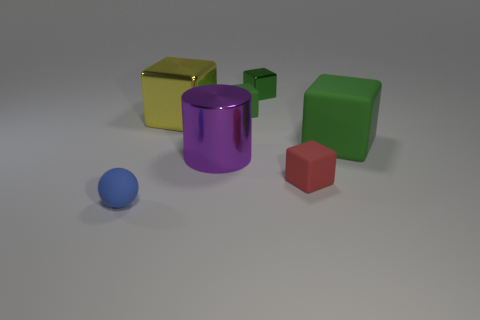Subtract all cyan cylinders. How many green cubes are left? 3 Add 1 tiny things. How many objects exist? 8 Subtract all green rubber blocks. How many blocks are left? 3 Subtract all red cubes. How many cubes are left? 4 Subtract 2 cubes. How many cubes are left? 3 Subtract 0 blue cylinders. How many objects are left? 7 Subtract all cubes. How many objects are left? 2 Subtract all cyan blocks. Subtract all blue spheres. How many blocks are left? 5 Subtract all small green rubber cubes. Subtract all metallic cubes. How many objects are left? 4 Add 2 blue rubber things. How many blue rubber things are left? 3 